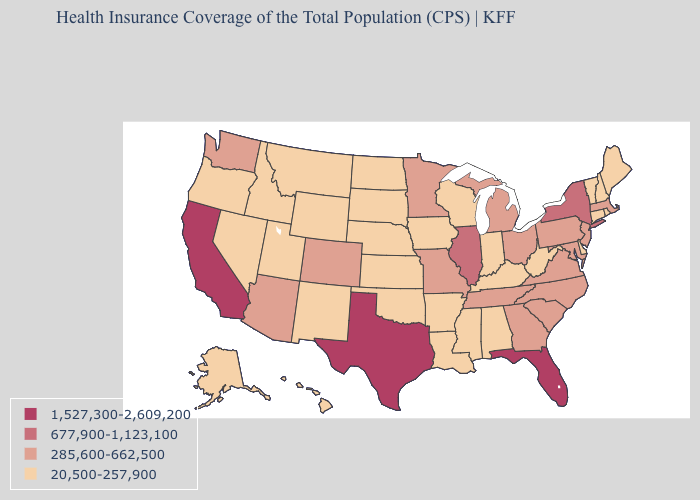How many symbols are there in the legend?
Give a very brief answer. 4. What is the lowest value in the West?
Short answer required. 20,500-257,900. Name the states that have a value in the range 20,500-257,900?
Keep it brief. Alabama, Alaska, Arkansas, Connecticut, Delaware, Hawaii, Idaho, Indiana, Iowa, Kansas, Kentucky, Louisiana, Maine, Mississippi, Montana, Nebraska, Nevada, New Hampshire, New Mexico, North Dakota, Oklahoma, Oregon, Rhode Island, South Dakota, Utah, Vermont, West Virginia, Wisconsin, Wyoming. Does the map have missing data?
Short answer required. No. Does the map have missing data?
Concise answer only. No. What is the value of Oregon?
Short answer required. 20,500-257,900. What is the value of Idaho?
Give a very brief answer. 20,500-257,900. Name the states that have a value in the range 1,527,300-2,609,200?
Write a very short answer. California, Florida, Texas. What is the value of Tennessee?
Short answer required. 285,600-662,500. Does the map have missing data?
Be succinct. No. Does Oklahoma have the highest value in the USA?
Concise answer only. No. Name the states that have a value in the range 677,900-1,123,100?
Be succinct. Illinois, New York. What is the value of North Dakota?
Quick response, please. 20,500-257,900. Among the states that border Arkansas , which have the lowest value?
Concise answer only. Louisiana, Mississippi, Oklahoma. Which states have the lowest value in the USA?
Answer briefly. Alabama, Alaska, Arkansas, Connecticut, Delaware, Hawaii, Idaho, Indiana, Iowa, Kansas, Kentucky, Louisiana, Maine, Mississippi, Montana, Nebraska, Nevada, New Hampshire, New Mexico, North Dakota, Oklahoma, Oregon, Rhode Island, South Dakota, Utah, Vermont, West Virginia, Wisconsin, Wyoming. 